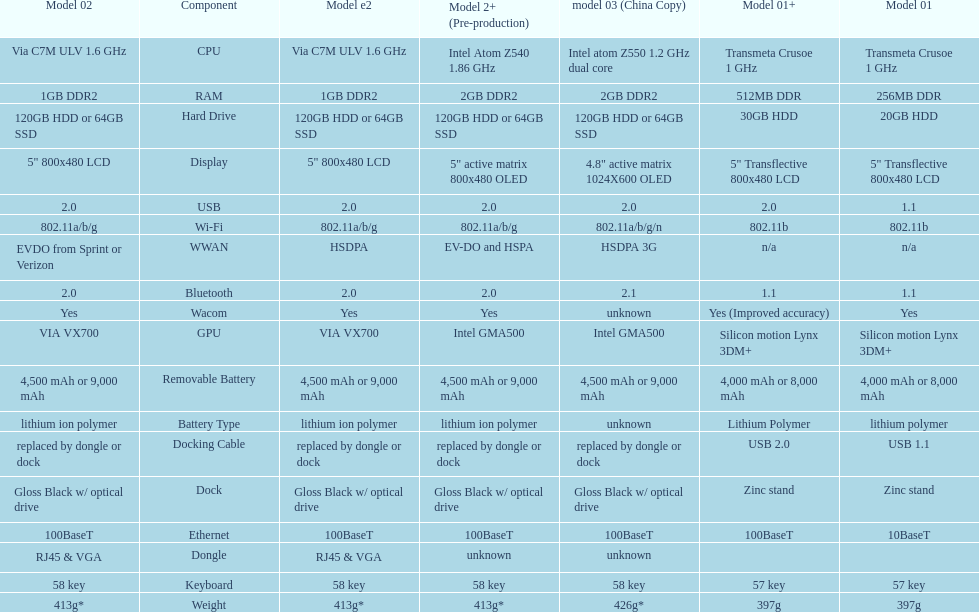What is the next highest hard drive available after the 30gb model? 64GB SSD. Write the full table. {'header': ['Model 02', 'Component', 'Model e2', 'Model 2+ (Pre-production)', 'model 03 (China Copy)', 'Model 01+', 'Model 01'], 'rows': [['Via C7M ULV 1.6\xa0GHz', 'CPU', 'Via C7M ULV 1.6\xa0GHz', 'Intel Atom Z540 1.86\xa0GHz', 'Intel atom Z550 1.2\xa0GHz dual core', 'Transmeta Crusoe 1\xa0GHz', 'Transmeta Crusoe 1\xa0GHz'], ['1GB DDR2', 'RAM', '1GB DDR2', '2GB DDR2', '2GB DDR2', '512MB DDR', '256MB DDR'], ['120GB HDD or 64GB SSD', 'Hard Drive', '120GB HDD or 64GB SSD', '120GB HDD or 64GB SSD', '120GB HDD or 64GB SSD', '30GB HDD', '20GB HDD'], ['5" 800x480 LCD', 'Display', '5" 800x480 LCD', '5" active matrix 800x480 OLED', '4.8" active matrix 1024X600 OLED', '5" Transflective 800x480 LCD', '5" Transflective 800x480 LCD'], ['2.0', 'USB', '2.0', '2.0', '2.0', '2.0', '1.1'], ['802.11a/b/g', 'Wi-Fi', '802.11a/b/g', '802.11a/b/g', '802.11a/b/g/n', '802.11b', '802.11b'], ['EVDO from Sprint or Verizon', 'WWAN', 'HSDPA', 'EV-DO and HSPA', 'HSDPA 3G', 'n/a', 'n/a'], ['2.0', 'Bluetooth', '2.0', '2.0', '2.1', '1.1', '1.1'], ['Yes', 'Wacom', 'Yes', 'Yes', 'unknown', 'Yes (Improved accuracy)', 'Yes'], ['VIA VX700', 'GPU', 'VIA VX700', 'Intel GMA500', 'Intel GMA500', 'Silicon motion Lynx 3DM+', 'Silicon motion Lynx 3DM+'], ['4,500 mAh or 9,000 mAh', 'Removable Battery', '4,500 mAh or 9,000 mAh', '4,500 mAh or 9,000 mAh', '4,500 mAh or 9,000 mAh', '4,000 mAh or 8,000 mAh', '4,000 mAh or 8,000 mAh'], ['lithium ion polymer', 'Battery Type', 'lithium ion polymer', 'lithium ion polymer', 'unknown', 'Lithium Polymer', 'lithium polymer'], ['replaced by dongle or dock', 'Docking Cable', 'replaced by dongle or dock', 'replaced by dongle or dock', 'replaced by dongle or dock', 'USB 2.0', 'USB 1.1'], ['Gloss Black w/ optical drive', 'Dock', 'Gloss Black w/ optical drive', 'Gloss Black w/ optical drive', 'Gloss Black w/ optical drive', 'Zinc stand', 'Zinc stand'], ['100BaseT', 'Ethernet', '100BaseT', '100BaseT', '100BaseT', '100BaseT', '10BaseT'], ['RJ45 & VGA', 'Dongle', 'RJ45 & VGA', 'unknown', 'unknown', '', ''], ['58 key', 'Keyboard', '58 key', '58 key', '58 key', '57 key', '57 key'], ['413g*', 'Weight', '413g*', '413g*', '426g*', '397g', '397g']]} 